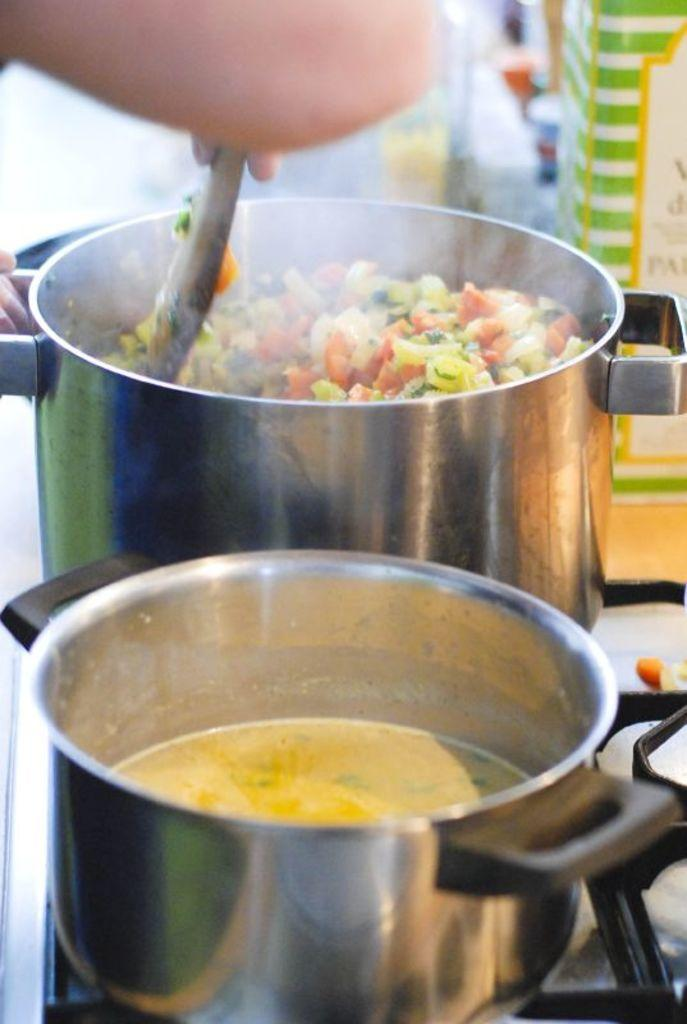What can be seen in the image related to food preparation? There are two vessels with food items on a stove in the image. What is the person's hand holding in the image? The person's hand is holding a spoon in the image. What type of sign is the person holding in the image? There is no sign present in the image; the person's hand is holding a spoon. What color is the dress the person is wearing in the image? There is no person wearing a dress in the image; the focus is on the food preparation. 